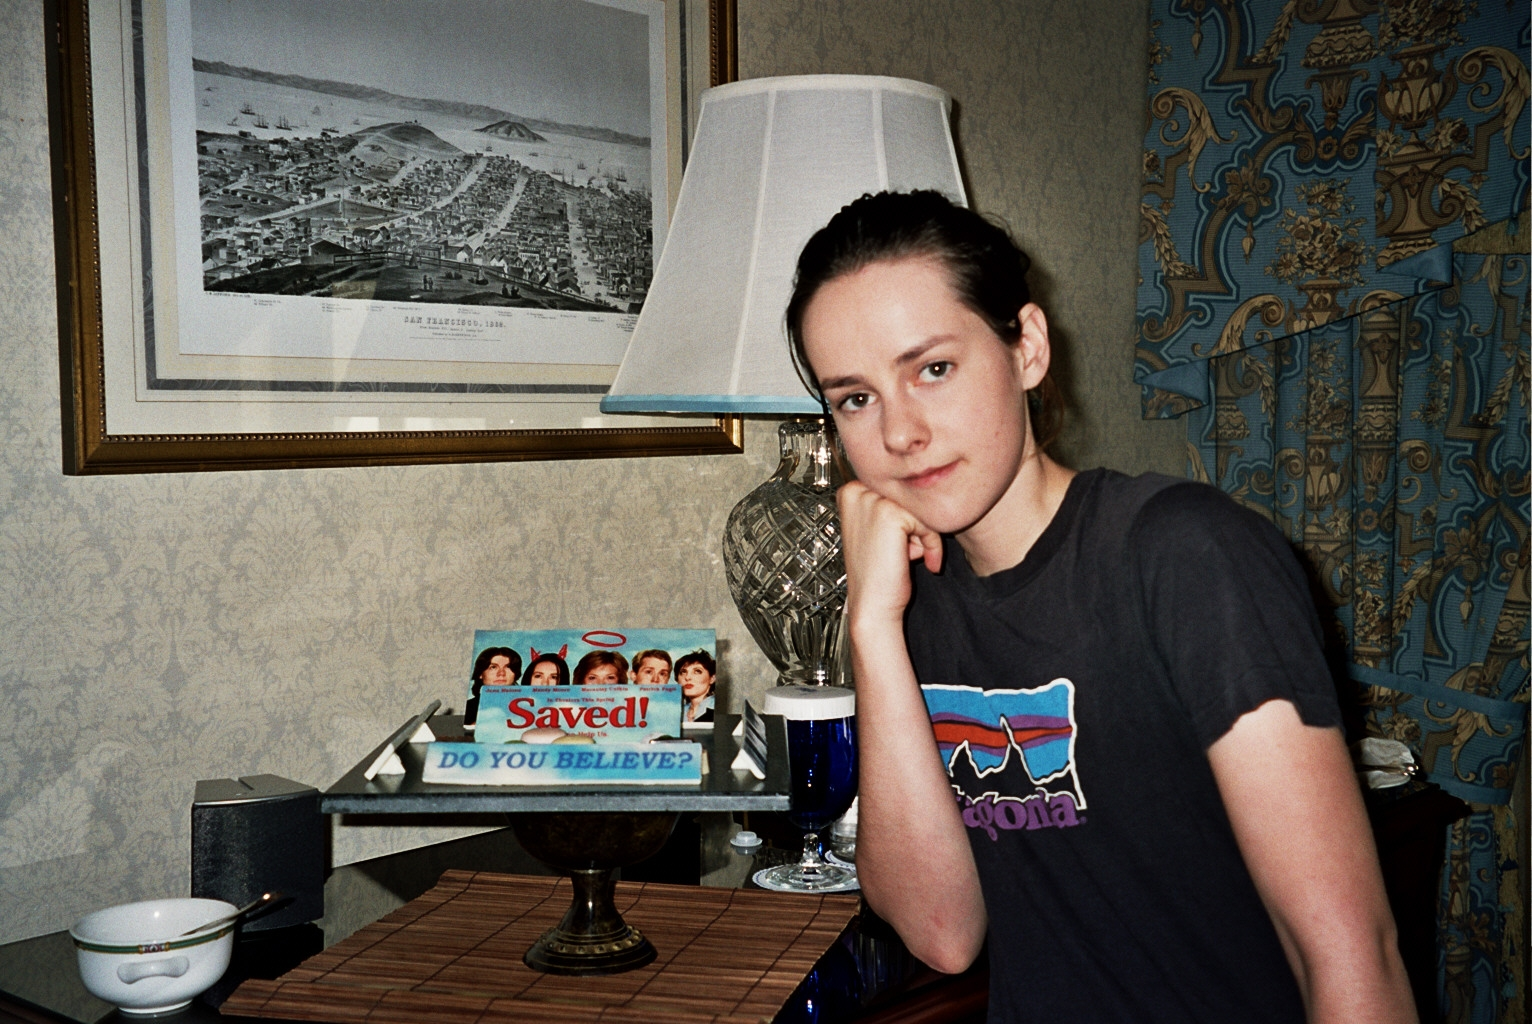What might be the significance of the movie 'Saved!' in this scene? The inclusion of the movie 'Saved!' could signify a moment of reflection or a cherished memory associated with the film. It might be a favorite movie that resonates with the individual, offering deeper themes of belief, identity, and belonging which align with their personal experiences or introspections. 